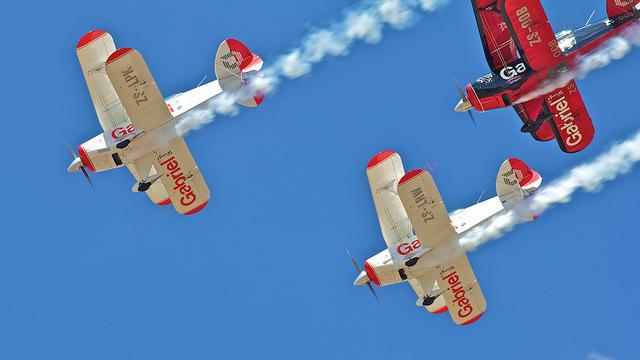How many planes can be seen?
Be succinct. 3. What is trailing behind the airplanes?
Quick response, please. Smoke. Are these modern airplanes?
Be succinct. No. 